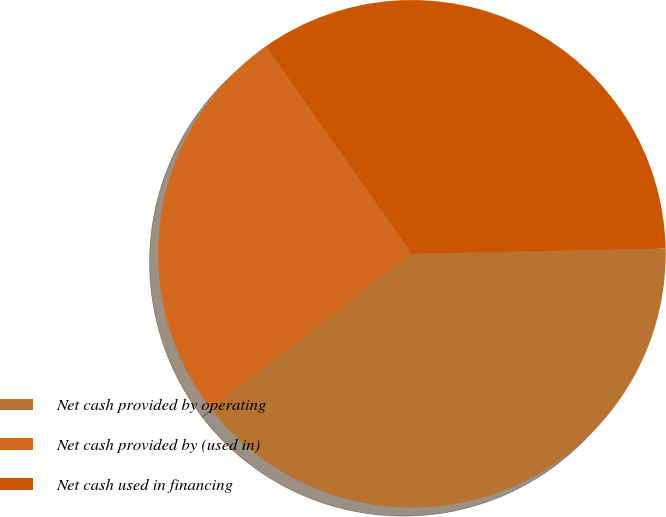Convert chart to OTSL. <chart><loc_0><loc_0><loc_500><loc_500><pie_chart><fcel>Net cash provided by operating<fcel>Net cash provided by (used in)<fcel>Net cash used in financing<nl><fcel>39.9%<fcel>25.68%<fcel>34.42%<nl></chart> 